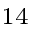Convert formula to latex. <formula><loc_0><loc_0><loc_500><loc_500>^ { 1 4 }</formula> 